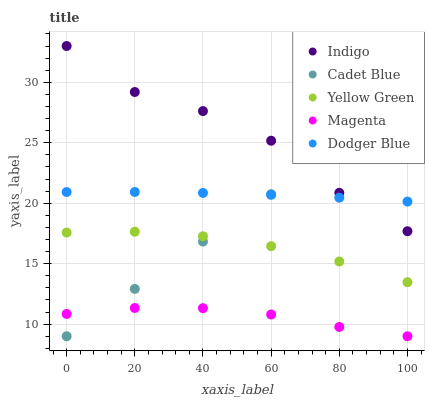Does Magenta have the minimum area under the curve?
Answer yes or no. Yes. Does Indigo have the maximum area under the curve?
Answer yes or no. Yes. Does Cadet Blue have the minimum area under the curve?
Answer yes or no. No. Does Cadet Blue have the maximum area under the curve?
Answer yes or no. No. Is Cadet Blue the smoothest?
Answer yes or no. Yes. Is Indigo the roughest?
Answer yes or no. Yes. Is Magenta the smoothest?
Answer yes or no. No. Is Magenta the roughest?
Answer yes or no. No. Does Magenta have the lowest value?
Answer yes or no. Yes. Does Indigo have the lowest value?
Answer yes or no. No. Does Indigo have the highest value?
Answer yes or no. Yes. Does Cadet Blue have the highest value?
Answer yes or no. No. Is Magenta less than Dodger Blue?
Answer yes or no. Yes. Is Yellow Green greater than Magenta?
Answer yes or no. Yes. Does Dodger Blue intersect Cadet Blue?
Answer yes or no. Yes. Is Dodger Blue less than Cadet Blue?
Answer yes or no. No. Is Dodger Blue greater than Cadet Blue?
Answer yes or no. No. Does Magenta intersect Dodger Blue?
Answer yes or no. No. 